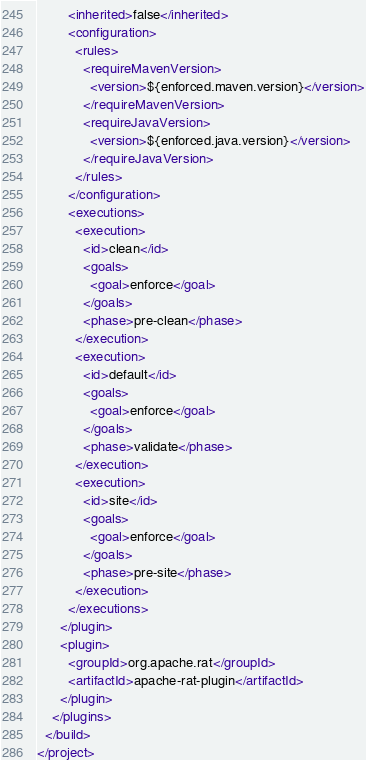<code> <loc_0><loc_0><loc_500><loc_500><_XML_>        <inherited>false</inherited>
        <configuration>
          <rules>
            <requireMavenVersion>
              <version>${enforced.maven.version}</version>
            </requireMavenVersion>
            <requireJavaVersion>
              <version>${enforced.java.version}</version>
            </requireJavaVersion>
          </rules>
        </configuration>
        <executions>
          <execution>
            <id>clean</id>
            <goals>
              <goal>enforce</goal>
            </goals>
            <phase>pre-clean</phase>
          </execution>
          <execution>
            <id>default</id>
            <goals>
              <goal>enforce</goal>
            </goals>
            <phase>validate</phase>
          </execution>
          <execution>
            <id>site</id>
            <goals>
              <goal>enforce</goal>
            </goals>
            <phase>pre-site</phase>
          </execution>
        </executions>
      </plugin>
      <plugin>
        <groupId>org.apache.rat</groupId>
        <artifactId>apache-rat-plugin</artifactId>
      </plugin>
    </plugins>
  </build>
</project>
</code> 